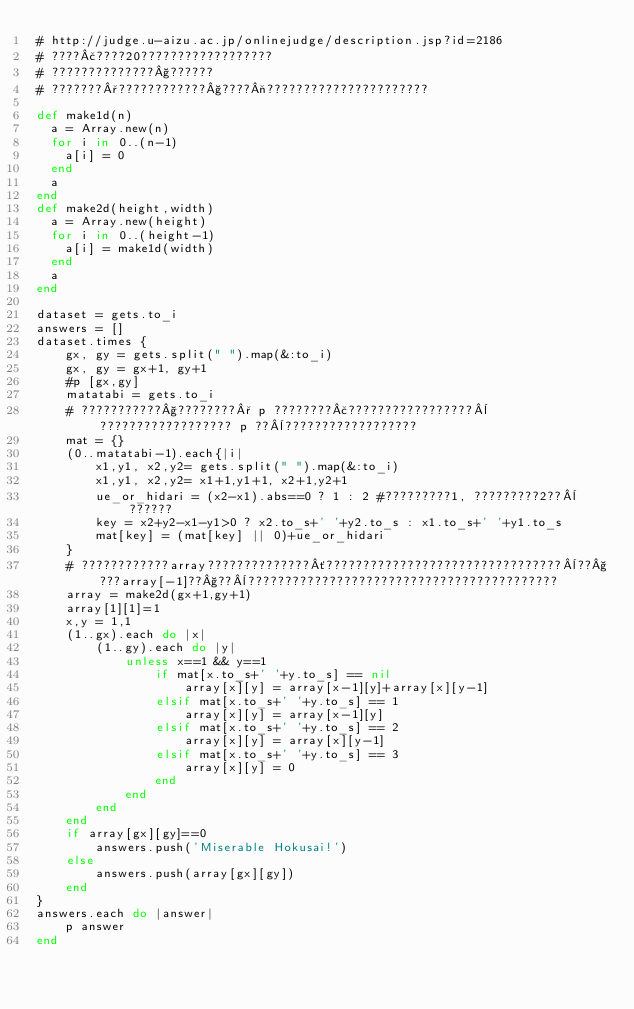<code> <loc_0><loc_0><loc_500><loc_500><_Ruby_># http://judge.u-aizu.ac.jp/onlinejudge/description.jsp?id=2186
# ????£????20??????????????????
# ??????????????§??????
# ???????°????????????§????¬??????????????????????

def make1d(n)
  a = Array.new(n)
  for i in 0..(n-1)
    a[i] = 0
  end
  a
end
def make2d(height,width)
  a = Array.new(height)
  for i in 0..(height-1)
    a[i] = make1d(width)
  end
  a
end

dataset = gets.to_i
answers = []
dataset.times {
	gx, gy = gets.split(" ").map(&:to_i)
	gx, gy = gx+1, gy+1 
	#p [gx,gy]
	matatabi = gets.to_i
	# ???????????§????????° p ????????£?????????????????¨?????????????????? p ??¨??????????????????
	mat = {}
	(0..matatabi-1).each{|i|
		x1,y1, x2,y2= gets.split(" ").map(&:to_i)
		x1,y1, x2,y2= x1+1,y1+1, x2+1,y2+1
		ue_or_hidari = (x2-x1).abs==0 ? 1 : 2 #?????????1, ?????????2??¨??????
		key = x2+y2-x1-y1>0 ? x2.to_s+' '+y2.to_s : x1.to_s+' '+y1.to_s
		mat[key] = (mat[key] || 0)+ue_or_hidari
	}
	# ????????????array??????????????´????????????????????????????????¨??§???array[-1]??§??¨??????????????????????????????????????????
	array = make2d(gx+1,gy+1)
	array[1][1]=1
	x,y = 1,1
	(1..gx).each do |x|
		(1..gy).each do |y|
			unless x==1 && y==1
				if mat[x.to_s+' '+y.to_s] == nil
					array[x][y] = array[x-1][y]+array[x][y-1]
				elsif mat[x.to_s+' '+y.to_s] == 1
					array[x][y] = array[x-1][y]
				elsif mat[x.to_s+' '+y.to_s] == 2
					array[x][y] = array[x][y-1]
				elsif mat[x.to_s+' '+y.to_s] == 3
					array[x][y] = 0
				end
			end
		end
	end
	if array[gx][gy]==0
		answers.push('Miserable Hokusai!')
	else
		answers.push(array[gx][gy])
	end
}
answers.each do |answer|
	p answer
end</code> 